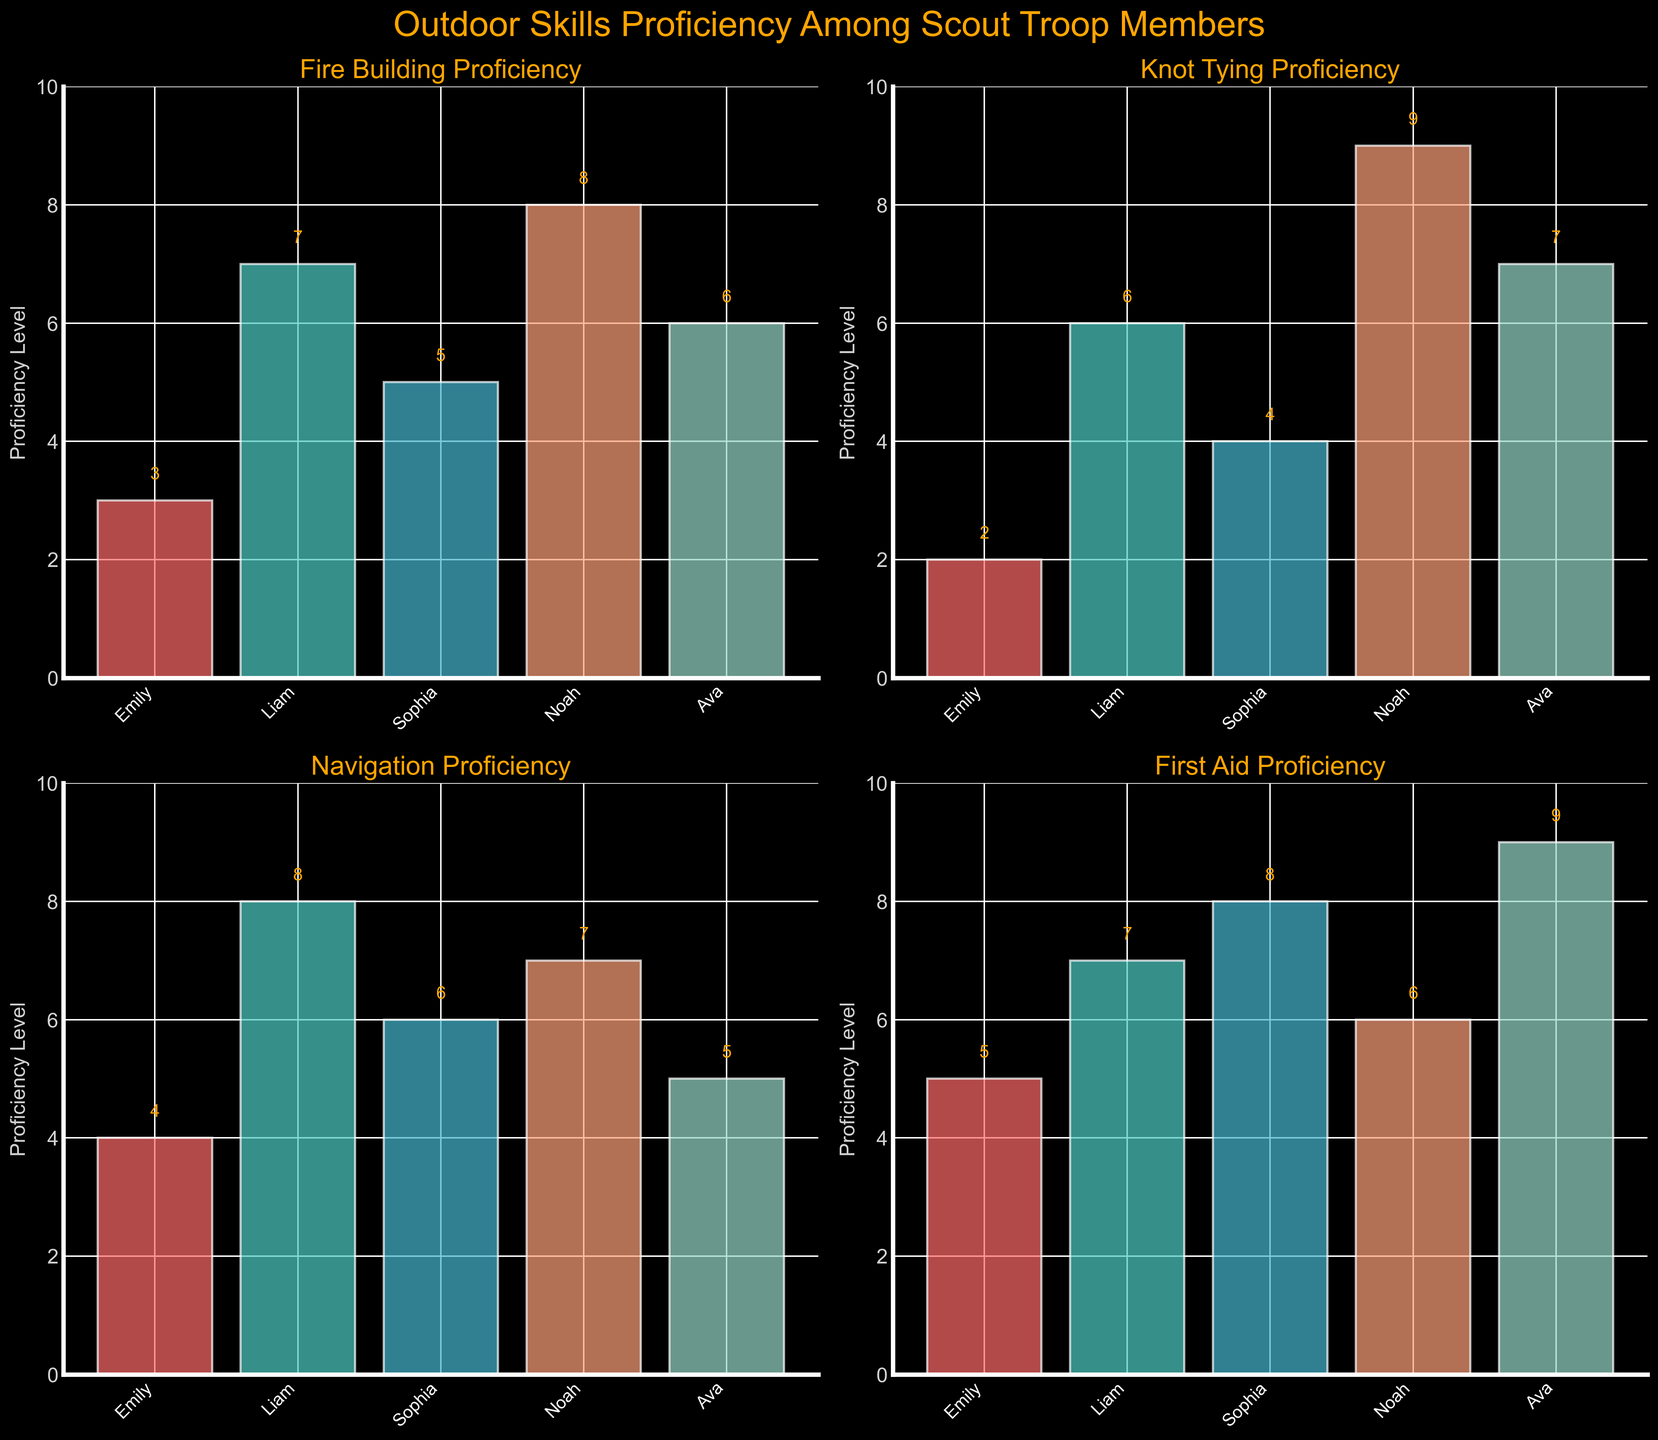Which scout has the highest proficiency level in Fire Building? Look at the bar heights in the Fire Building plot. Noah's bar is the tallest, indicating the highest proficiency level.
Answer: Noah What's the average proficiency level for Emily across all skills? Add Emily's proficiency levels across all skills (3 + 2 + 4 + 5), totaling 14, and then divide by the number of skills, which is 4.
Answer: 3.5 Which skill does Emily have the least proficiency in? Compare Emily's proficiency levels across all skills. The lowest value is in Knot Tying with a proficiency level of 2.
Answer: Knot Tying How many scouts have a proficiency level of 7 in Navigation? Check the Navigation plot and count the bars with a value of 7. Only Noah has a proficiency level of 7 in Navigation.
Answer: 1 Which skill has the highest average proficiency level across all scouts? Calculate the average proficiency for all scouts per skill. Fire Building: (3 + 7 + 5 + 8 + 6) / 5 = 5.8; Knot Tying: (2 + 6 + 4 + 9 + 7) / 5 = 5.6; Navigation: (4 + 8 + 6 + 7 + 5) / 5 = 6; First Aid: (5 + 7 + 8 + 6 + 9) / 5 = 7. The highest is First Aid with an average proficiency of 7.
Answer: First Aid What's the difference in proficiency levels between Liam and Sophia in First Aid? In the First Aid plot, Liam's proficiency is 7, and Sophia's is 8. The difference is 1.
Answer: 1 Which scout has the most consistent proficiency levels across all skills? Evaluate the variation in each scout's proficiency levels: Emily (3, 2, 4, 5), Liam (7, 6, 8, 7), Sophia (5, 4, 6, 8), Noah (8, 9, 7, 6), Ava (6, 7, 5, 9). Liam's proficiencies are the most close to each other with a small range (6 to 8).
Answer: Liam What's the total proficiency level of Ava in Fire Building and Navigation combined? Check Ava's proficiency levels in each respective plot. Fire Building: 6, Navigation: 5. Sum them up, so 6 + 5 = 11.
Answer: 11 